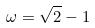Convert formula to latex. <formula><loc_0><loc_0><loc_500><loc_500>\omega = \sqrt { 2 } - 1</formula> 